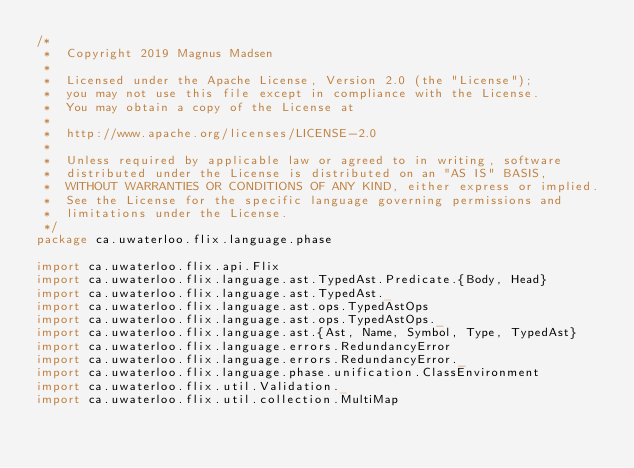Convert code to text. <code><loc_0><loc_0><loc_500><loc_500><_Scala_>/*
 *  Copyright 2019 Magnus Madsen
 *
 *  Licensed under the Apache License, Version 2.0 (the "License");
 *  you may not use this file except in compliance with the License.
 *  You may obtain a copy of the License at
 *
 *  http://www.apache.org/licenses/LICENSE-2.0
 *
 *  Unless required by applicable law or agreed to in writing, software
 *  distributed under the License is distributed on an "AS IS" BASIS,
 *  WITHOUT WARRANTIES OR CONDITIONS OF ANY KIND, either express or implied.
 *  See the License for the specific language governing permissions and
 *  limitations under the License.
 */
package ca.uwaterloo.flix.language.phase

import ca.uwaterloo.flix.api.Flix
import ca.uwaterloo.flix.language.ast.TypedAst.Predicate.{Body, Head}
import ca.uwaterloo.flix.language.ast.TypedAst._
import ca.uwaterloo.flix.language.ast.ops.TypedAstOps
import ca.uwaterloo.flix.language.ast.ops.TypedAstOps._
import ca.uwaterloo.flix.language.ast.{Ast, Name, Symbol, Type, TypedAst}
import ca.uwaterloo.flix.language.errors.RedundancyError
import ca.uwaterloo.flix.language.errors.RedundancyError._
import ca.uwaterloo.flix.language.phase.unification.ClassEnvironment
import ca.uwaterloo.flix.util.Validation._
import ca.uwaterloo.flix.util.collection.MultiMap</code> 